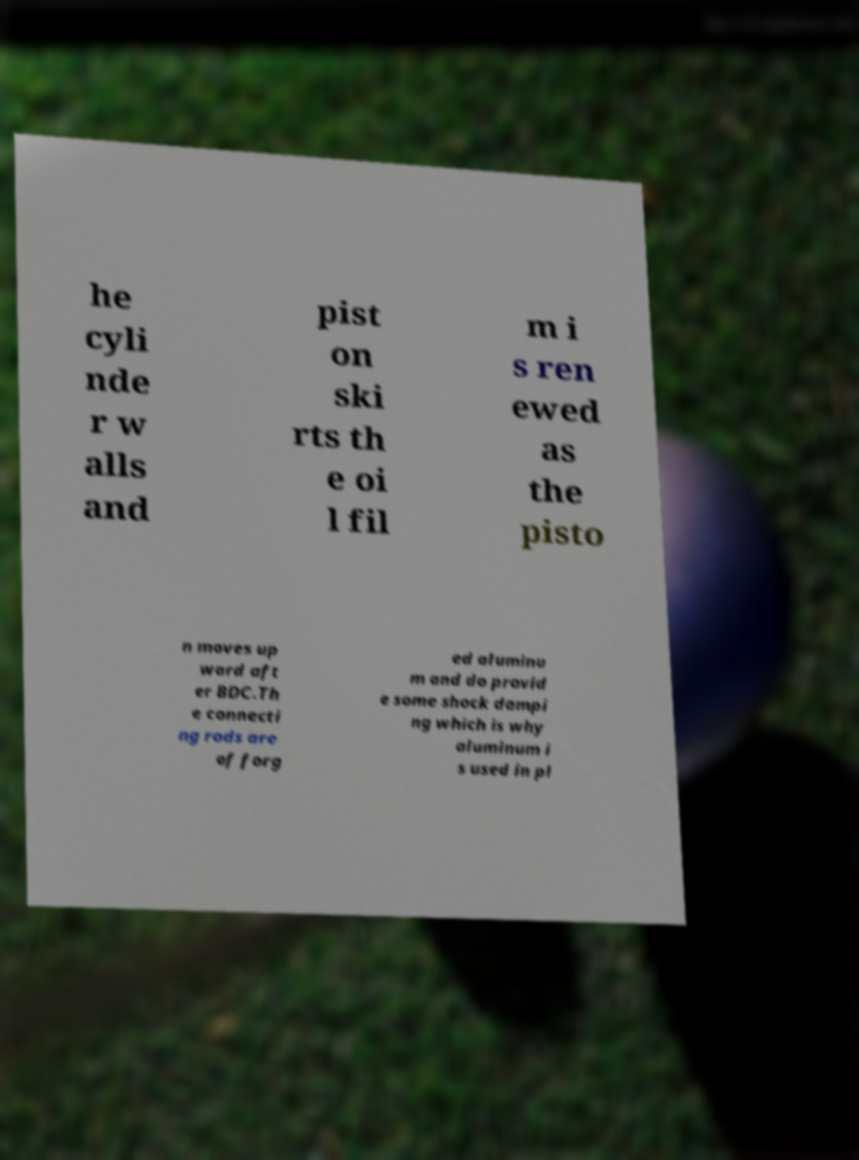For documentation purposes, I need the text within this image transcribed. Could you provide that? he cyli nde r w alls and pist on ski rts th e oi l fil m i s ren ewed as the pisto n moves up ward aft er BDC.Th e connecti ng rods are of forg ed aluminu m and do provid e some shock dampi ng which is why aluminum i s used in pl 